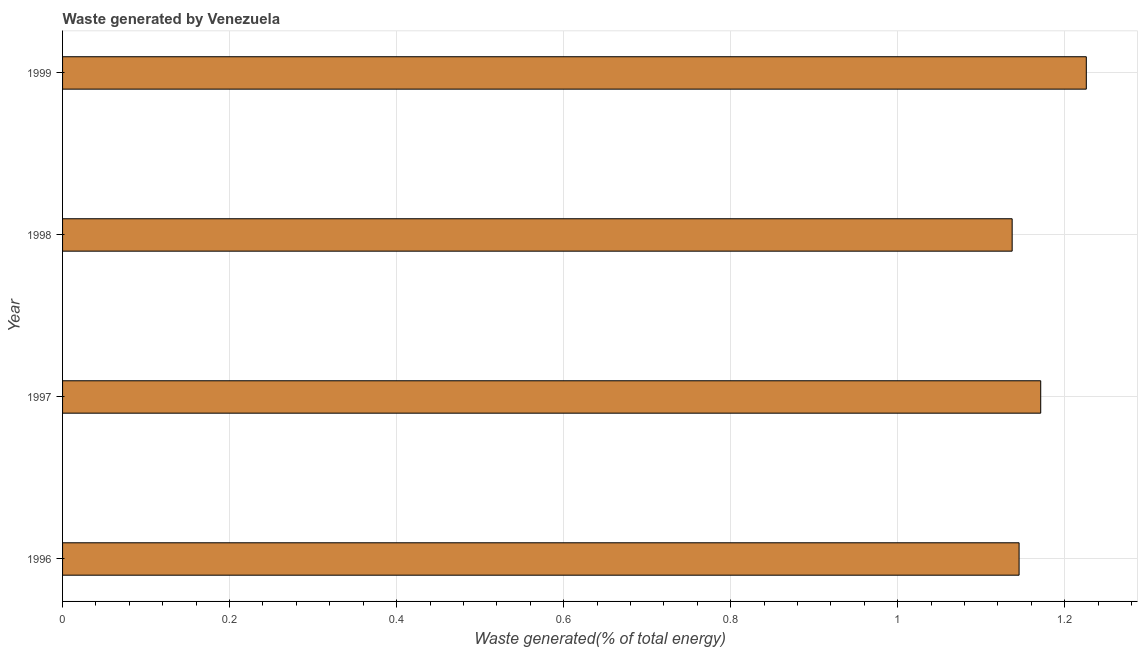Does the graph contain any zero values?
Your answer should be very brief. No. Does the graph contain grids?
Keep it short and to the point. Yes. What is the title of the graph?
Keep it short and to the point. Waste generated by Venezuela. What is the label or title of the X-axis?
Provide a short and direct response. Waste generated(% of total energy). What is the label or title of the Y-axis?
Provide a succinct answer. Year. What is the amount of waste generated in 1998?
Ensure brevity in your answer.  1.14. Across all years, what is the maximum amount of waste generated?
Your answer should be compact. 1.23. Across all years, what is the minimum amount of waste generated?
Provide a short and direct response. 1.14. In which year was the amount of waste generated maximum?
Give a very brief answer. 1999. What is the sum of the amount of waste generated?
Make the answer very short. 4.68. What is the difference between the amount of waste generated in 1996 and 1998?
Offer a very short reply. 0.01. What is the average amount of waste generated per year?
Offer a very short reply. 1.17. What is the median amount of waste generated?
Your answer should be very brief. 1.16. What is the ratio of the amount of waste generated in 1997 to that in 1999?
Your response must be concise. 0.95. What is the difference between the highest and the second highest amount of waste generated?
Keep it short and to the point. 0.06. What is the difference between the highest and the lowest amount of waste generated?
Your answer should be very brief. 0.09. Are the values on the major ticks of X-axis written in scientific E-notation?
Your response must be concise. No. What is the Waste generated(% of total energy) of 1996?
Make the answer very short. 1.15. What is the Waste generated(% of total energy) of 1997?
Provide a succinct answer. 1.17. What is the Waste generated(% of total energy) in 1998?
Keep it short and to the point. 1.14. What is the Waste generated(% of total energy) in 1999?
Keep it short and to the point. 1.23. What is the difference between the Waste generated(% of total energy) in 1996 and 1997?
Your answer should be very brief. -0.03. What is the difference between the Waste generated(% of total energy) in 1996 and 1998?
Offer a very short reply. 0.01. What is the difference between the Waste generated(% of total energy) in 1996 and 1999?
Give a very brief answer. -0.08. What is the difference between the Waste generated(% of total energy) in 1997 and 1998?
Offer a very short reply. 0.03. What is the difference between the Waste generated(% of total energy) in 1997 and 1999?
Make the answer very short. -0.05. What is the difference between the Waste generated(% of total energy) in 1998 and 1999?
Your answer should be very brief. -0.09. What is the ratio of the Waste generated(% of total energy) in 1996 to that in 1997?
Keep it short and to the point. 0.98. What is the ratio of the Waste generated(% of total energy) in 1996 to that in 1998?
Offer a very short reply. 1.01. What is the ratio of the Waste generated(% of total energy) in 1996 to that in 1999?
Provide a short and direct response. 0.93. What is the ratio of the Waste generated(% of total energy) in 1997 to that in 1999?
Offer a very short reply. 0.95. What is the ratio of the Waste generated(% of total energy) in 1998 to that in 1999?
Ensure brevity in your answer.  0.93. 